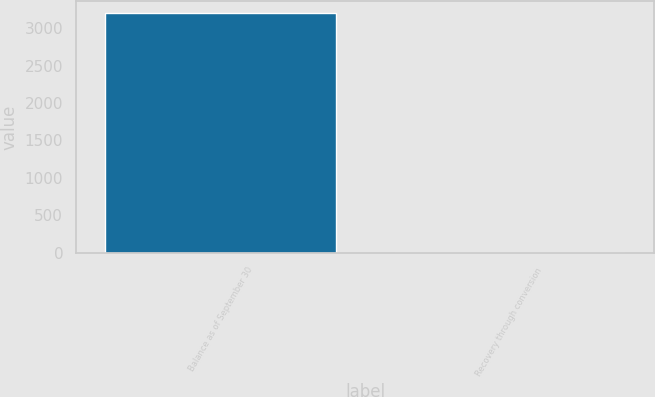Convert chart. <chart><loc_0><loc_0><loc_500><loc_500><bar_chart><fcel>Balance as of September 30<fcel>Recovery through conversion<nl><fcel>3200<fcel>1<nl></chart> 